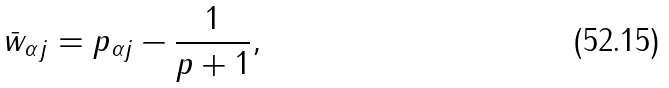Convert formula to latex. <formula><loc_0><loc_0><loc_500><loc_500>\bar { w } _ { \alpha j } = p _ { \alpha j } - \frac { 1 } { p + 1 } ,</formula> 